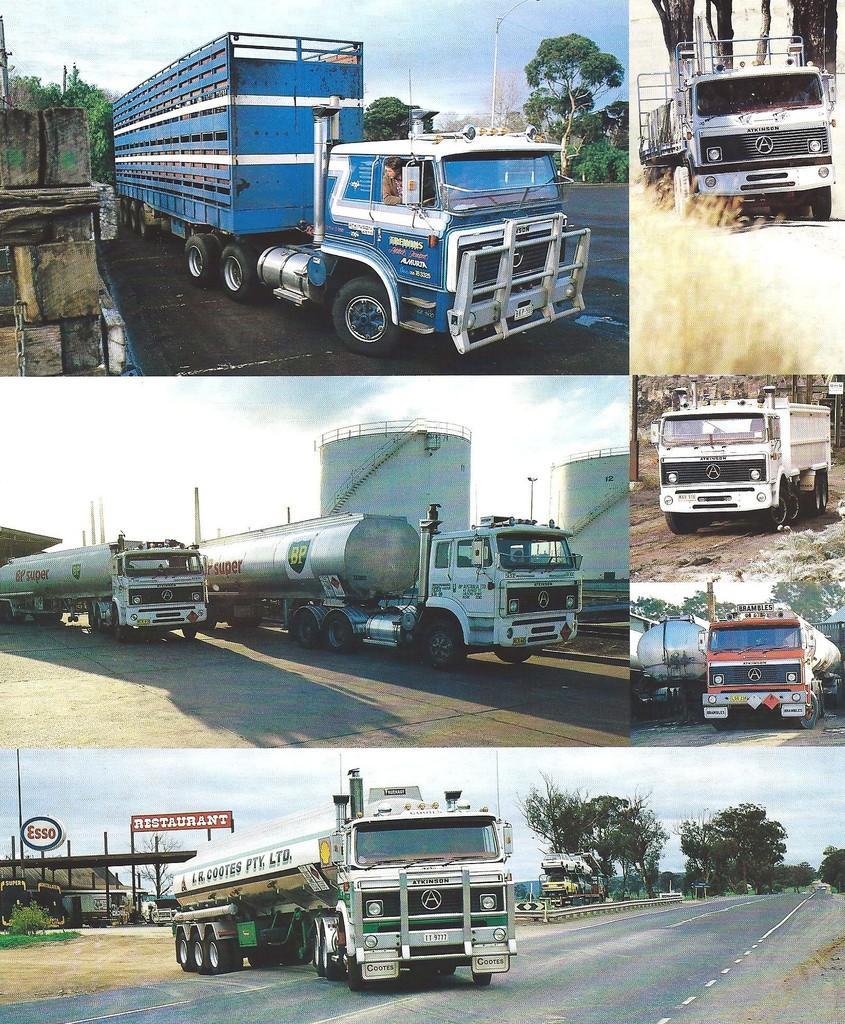Can you describe this image briefly? This is a collage image. Here I can see five images. In all the images I can see the trucks on the roads. In the background there are trees. At the top I can see the sky. 